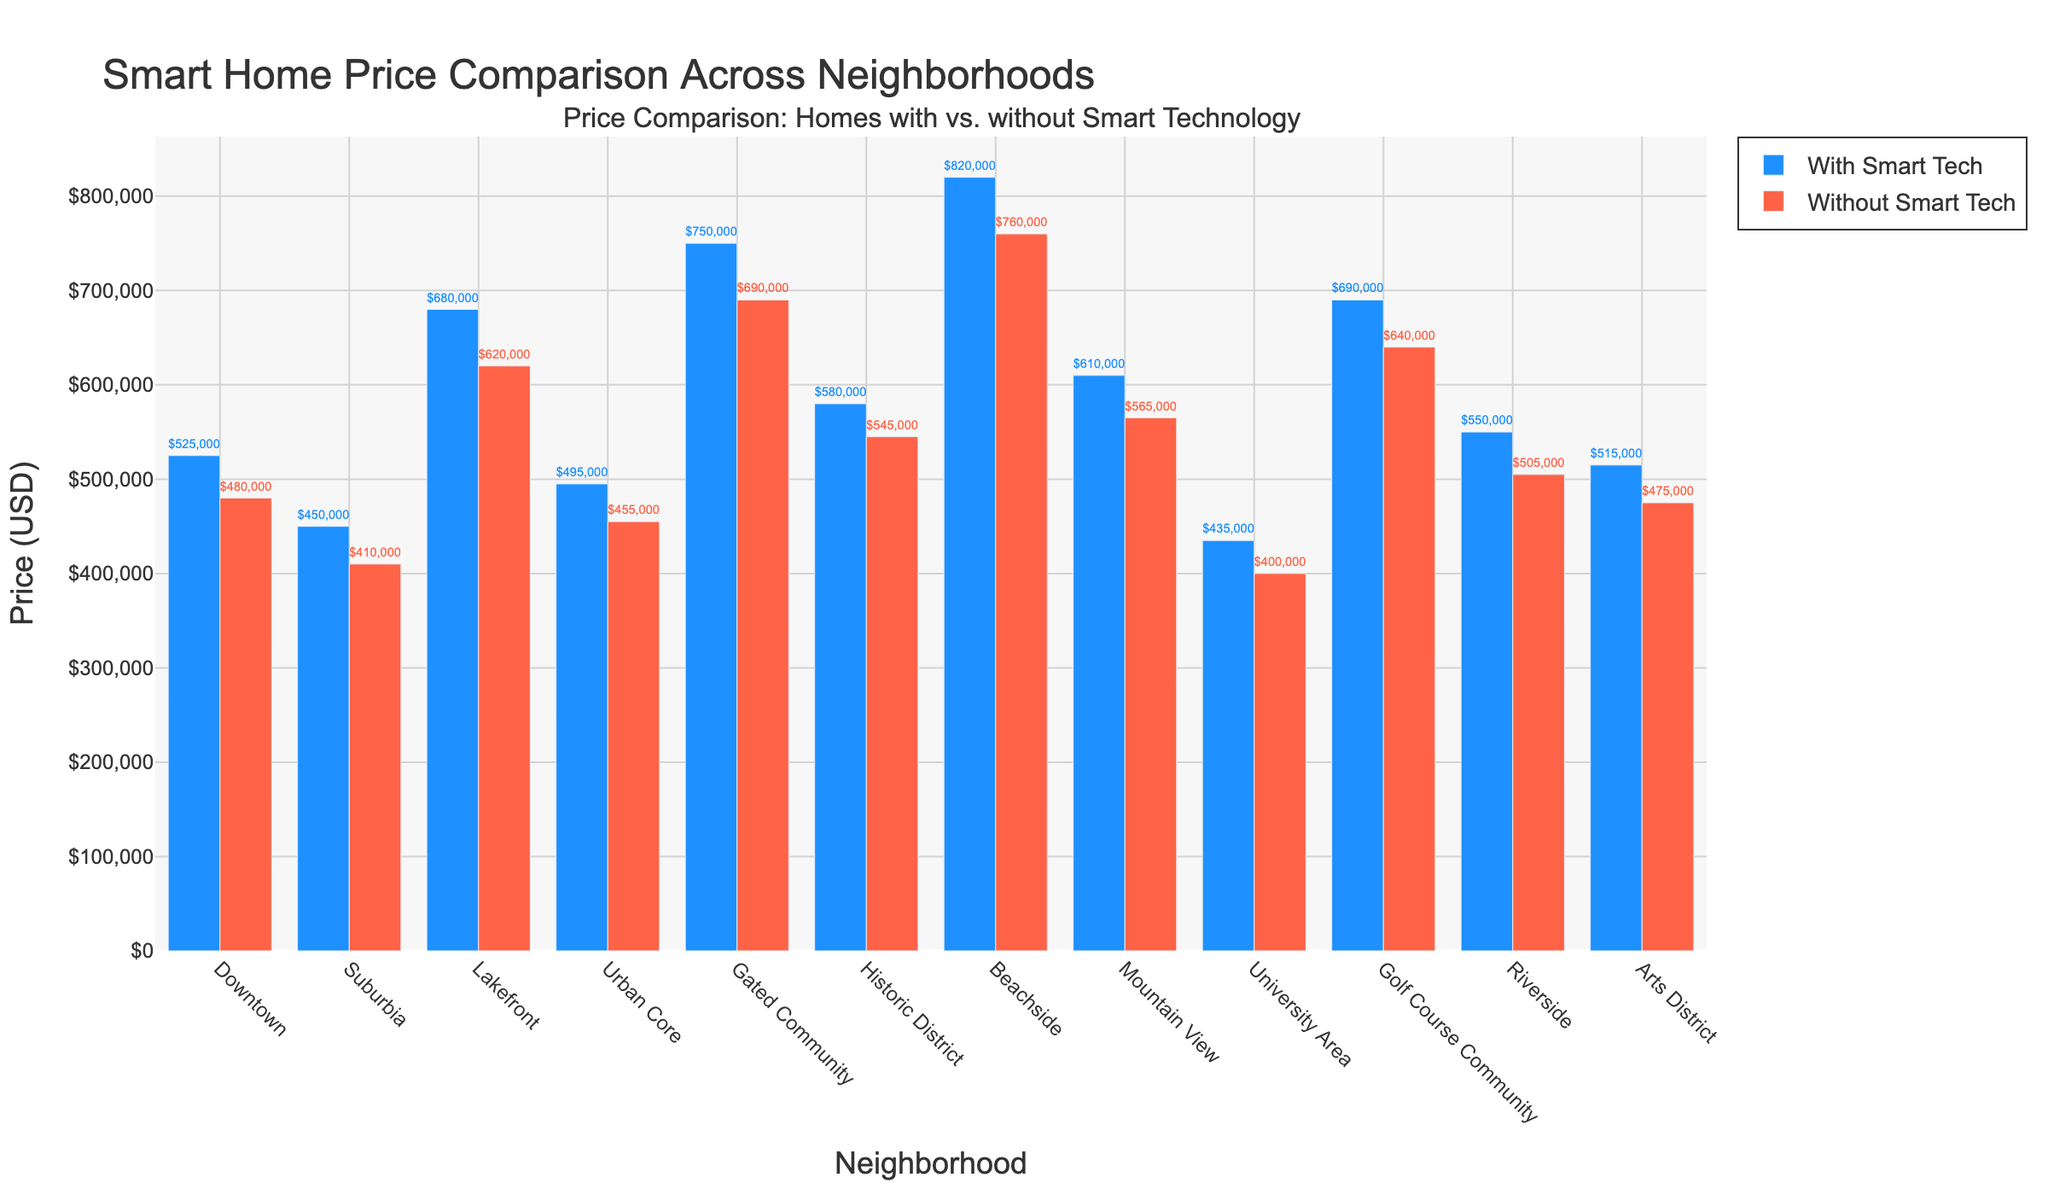Which neighborhood has the highest price for homes with smart technology? The neighborhood with the highest bar for homes with smart technology represents the highest price. In this case, the tallest blue bar corresponds to Beachside.
Answer: Beachside What's the average price of homes with and without smart technology in Downtown? First, we get the prices for homes with and without smart technology in Downtown: $525,000 and $480,000 respectively. Then, calculate the average: (525000 + 480000) / 2 = 1,005,000 / 2
Answer: $502,500 How much more expensive are homes with smart technology in the Gated Community compared to those without? Look at the bars for the Gated Community: $750,000 (with) and $690,000 (without). Subtract the price without smart tech from the price with smart tech: 750000 - 690000
Answer: $60,000 Which neighborhood has the smallest price difference between homes with and without smart technology? To find this, we examine each neighborhood's price and calculate the difference. The smallest difference is observed in the University Area: 435000 - 400000 = 35000
Answer: University Area In which neighborhood do homes without smart technology have the highest price? The tallest red bar represents the neighborhood where homes without smart technology are the most expensive. This corresponds to Beachside.
Answer: Beachside What is the total price of homes with smart technology in the University Area and the Arts District combined? Add the prices from both neighborhoods: University Area ($435,000) and Arts District ($515,000). 435000 + 515000
Answer: $950,000 Is the price of homes without smart technology in Urban Core higher or lower compared to Riverside? Compare the heights of the red bars for Urban Core ($455,000) and Riverside ($505,000). Urban Core is lower.
Answer: Lower How much cheaper is the average price of homes without smart technology compared to those with it across all neighborhoods? Calculate the average price for both categories. For 'With Smart Tech': (525000 + 450000 + 680000 + 495000 + 750000 + 580000 + 820000 + 610000 + 435000 + 690000 + 550000 + 515000)/12 = 620416.67. For 'Without Smart Tech': (480000 + 410000 + 620000 + 455000 + 690000 + 545000 + 760000 + 565000 + 400000 + 640000 + 505000 + 475000)/12 = 554166.67. Average difference: 620416.67 - 554166.67
Answer: $66,250 Which neighborhood shows the greatest relative increase in price when comparing homes with smart technology to without? Calculate the relative increase for each neighborhood: ((Price with Smart Tech - Price without Smart Tech) / Price without Smart Tech) * 100. The greatest percentage increase is 10.64% in Downtown (relative increase: ((525000 - 480000) / 480000) * 100).
Answer: Downtown 